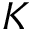Convert formula to latex. <formula><loc_0><loc_0><loc_500><loc_500>K</formula> 